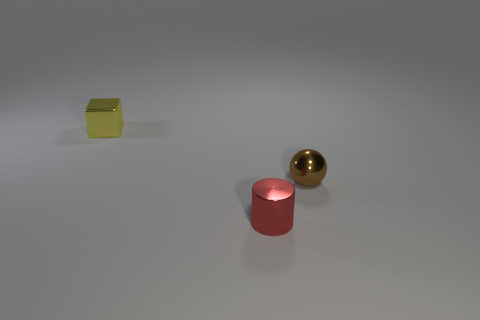Add 2 tiny red metal cylinders. How many objects exist? 5 Subtract all cylinders. How many objects are left? 2 Subtract all small blue metallic balls. Subtract all shiny blocks. How many objects are left? 2 Add 3 brown shiny objects. How many brown shiny objects are left? 4 Add 1 tiny shiny balls. How many tiny shiny balls exist? 2 Subtract 0 green cylinders. How many objects are left? 3 Subtract all purple cubes. Subtract all yellow cylinders. How many cubes are left? 1 